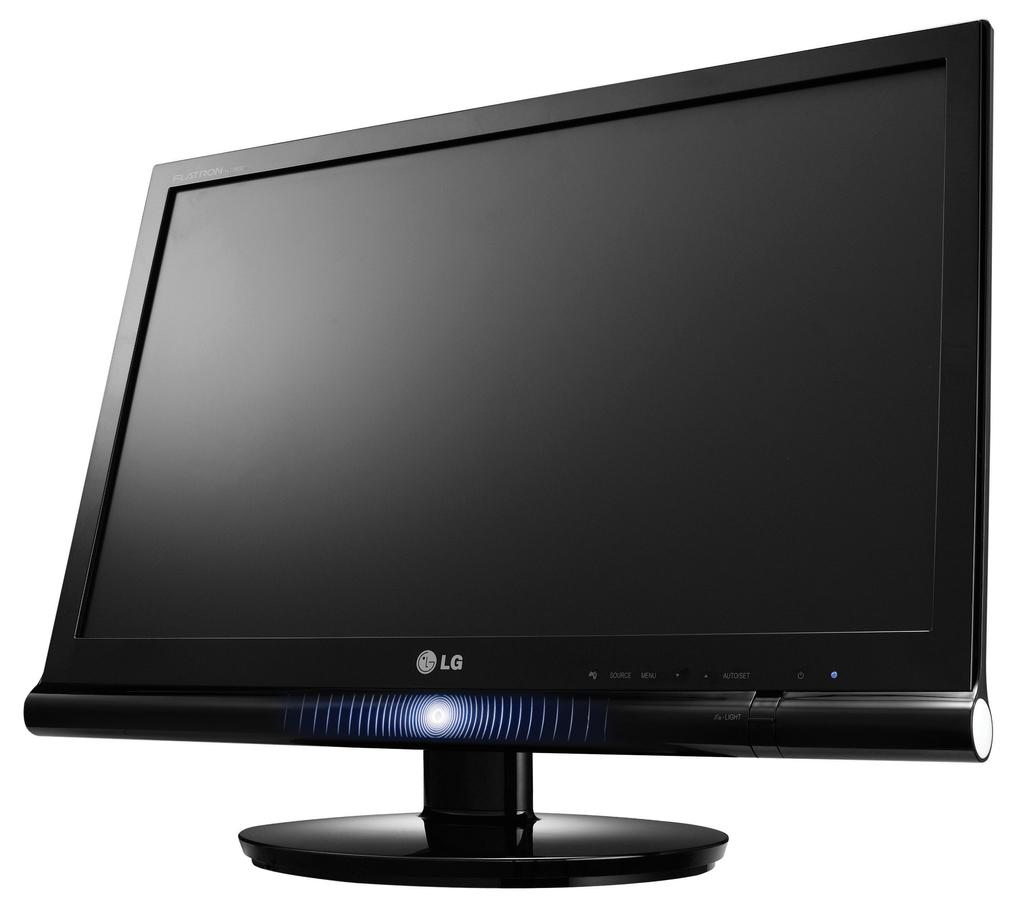<image>
Write a terse but informative summary of the picture. A monitor with the letters LG on the bottom. 